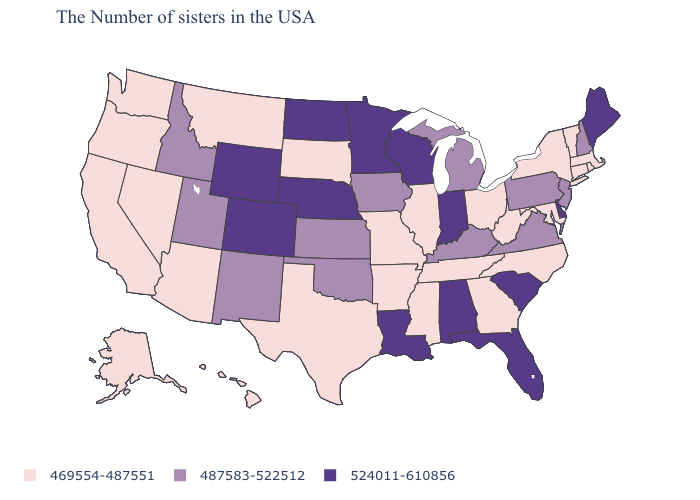Does Mississippi have the highest value in the USA?
Write a very short answer. No. Name the states that have a value in the range 487583-522512?
Concise answer only. New Hampshire, New Jersey, Pennsylvania, Virginia, Michigan, Kentucky, Iowa, Kansas, Oklahoma, New Mexico, Utah, Idaho. What is the value of New York?
Short answer required. 469554-487551. Among the states that border Mississippi , which have the highest value?
Give a very brief answer. Alabama, Louisiana. Name the states that have a value in the range 469554-487551?
Be succinct. Massachusetts, Rhode Island, Vermont, Connecticut, New York, Maryland, North Carolina, West Virginia, Ohio, Georgia, Tennessee, Illinois, Mississippi, Missouri, Arkansas, Texas, South Dakota, Montana, Arizona, Nevada, California, Washington, Oregon, Alaska, Hawaii. Which states hav the highest value in the West?
Short answer required. Wyoming, Colorado. Does Ohio have the same value as Arizona?
Concise answer only. Yes. Does Louisiana have a higher value than South Carolina?
Concise answer only. No. What is the value of Nevada?
Concise answer only. 469554-487551. Does West Virginia have the highest value in the USA?
Keep it brief. No. Is the legend a continuous bar?
Quick response, please. No. Which states hav the highest value in the MidWest?
Keep it brief. Indiana, Wisconsin, Minnesota, Nebraska, North Dakota. Does Mississippi have the lowest value in the South?
Answer briefly. Yes. Does Pennsylvania have the lowest value in the Northeast?
Short answer required. No. What is the value of Alaska?
Short answer required. 469554-487551. 